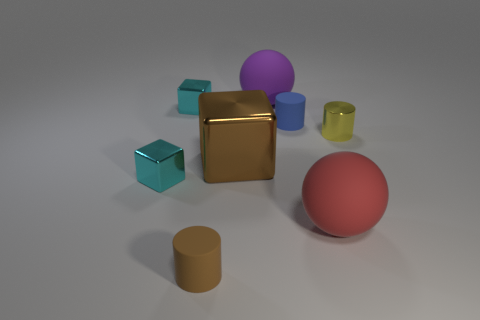Add 1 gray rubber cylinders. How many objects exist? 9 Subtract all cylinders. How many objects are left? 5 Add 4 brown shiny things. How many brown shiny things are left? 5 Add 5 small yellow metal cylinders. How many small yellow metal cylinders exist? 6 Subtract 0 green blocks. How many objects are left? 8 Subtract all cyan metallic things. Subtract all blocks. How many objects are left? 3 